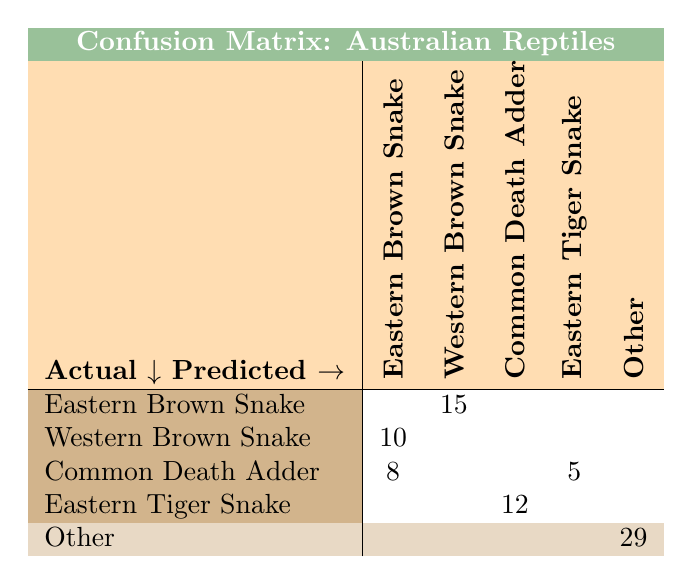What is the count of Eastern Brown Snakes predicted as Western Brown Snakes? The table shows a count of 15 under the column for Western Brown Snake and the row for Eastern Brown Snake. This means that out of all observations, 15 Eastern Brown Snakes were incorrectly identified as Western Brown Snakes.
Answer: 15 How many Western Brown Snakes were mistaken for Eastern Brown Snakes? Looking at the table, the count indicates that 10 Western Brown Snakes were predicted to be Eastern Brown Snakes, found in the row for Western Brown Snake and the column for Eastern Brown Snake.
Answer: 10 What is the total number of Common Death Adders that were incorrectly predicted as Eastern Tiger Snakes? In the table, the row for Common Death Adder shows a count of 5 under the column for Eastern Tiger Snake, indicating that 5 Common Death Adders were confused with Eastern Tiger Snakes.
Answer: 5 Is there any confusion between the Centralian Rough Knob-tail Gecko and Knob-tail Gecko? Yes, the table shows that 7 Centralian Rough Knob-tail Geckos were predicted as Knob-tail Geckos, while 6 Knob-tail Geckos were predicted as Centralian Rough Knob-tail Geckos, indicating mutual confusion.
Answer: Yes What is the total count of the Eastern Tiger Snakes that were confused with Common Death Adders? According to the table, the row for Eastern Tiger Snake indicates a count of 12 under the column for Common Death Adder, meaning 12 Eastern Tiger Snakes were confused as Common Death Adders.
Answer: 12 What is the proportion of Blue-tongue Lizards mistakenly identified as Shingleback Lizards? Referring to the table, 9 Blue-tongue Lizards were predicted as Shingleback Lizards out of a total of 12 (9 + 4 for Shingleback). The proportion is therefore 9 out of 13, which simplifies to approximately 0.692.
Answer: 0.692 How many total reptiles were recorded in the 'Other' category? The table shows that the 'Other' category has a total of 29 reptiles recorded, indicated in the 'Other' row and last column.
Answer: 29 Which snake has the highest number of misidentifications based on this table? The Eastern Brown Snake has 15 misidentifications (predicted as Western Brown Snake), which is the highest count compared to other snakes in the table.
Answer: Eastern Brown Snake 